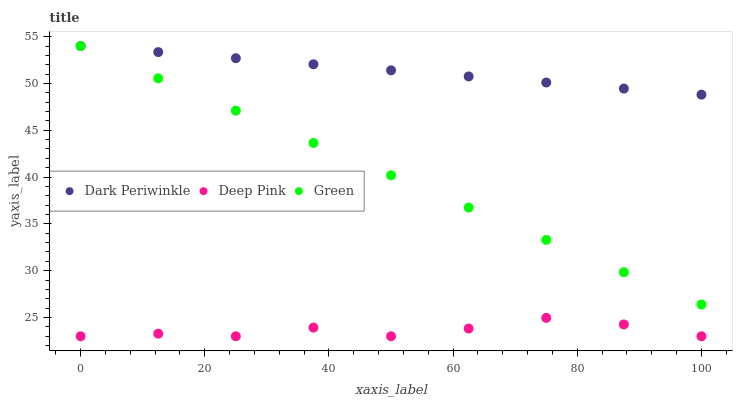Does Deep Pink have the minimum area under the curve?
Answer yes or no. Yes. Does Dark Periwinkle have the maximum area under the curve?
Answer yes or no. Yes. Does Green have the minimum area under the curve?
Answer yes or no. No. Does Green have the maximum area under the curve?
Answer yes or no. No. Is Green the smoothest?
Answer yes or no. Yes. Is Deep Pink the roughest?
Answer yes or no. Yes. Is Dark Periwinkle the smoothest?
Answer yes or no. No. Is Dark Periwinkle the roughest?
Answer yes or no. No. Does Deep Pink have the lowest value?
Answer yes or no. Yes. Does Green have the lowest value?
Answer yes or no. No. Does Dark Periwinkle have the highest value?
Answer yes or no. Yes. Is Deep Pink less than Green?
Answer yes or no. Yes. Is Dark Periwinkle greater than Deep Pink?
Answer yes or no. Yes. Does Dark Periwinkle intersect Green?
Answer yes or no. Yes. Is Dark Periwinkle less than Green?
Answer yes or no. No. Is Dark Periwinkle greater than Green?
Answer yes or no. No. Does Deep Pink intersect Green?
Answer yes or no. No. 